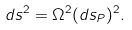Convert formula to latex. <formula><loc_0><loc_0><loc_500><loc_500>d s ^ { 2 } = \Omega ^ { 2 } ( d s _ { P } ) ^ { 2 } .</formula> 